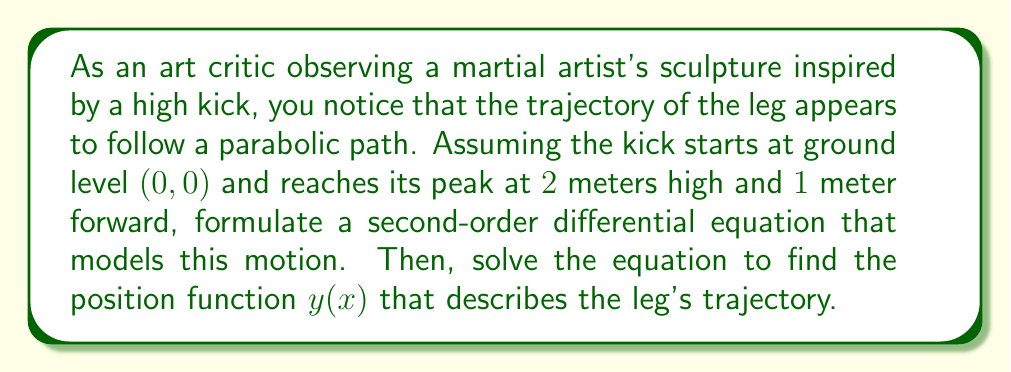Show me your answer to this math problem. Let's approach this step-by-step:

1) The parabolic trajectory suggests that the acceleration is constant (like gravity). We can model this with a second-order differential equation:

   $$\frac{d^2y}{dx^2} = k$$

   where $k$ is a constant.

2) We know three points on the trajectory:
   - Start: (0,0)
   - Peak: (1,2)
   - End: (2,0) (assuming symmetry)

3) The general solution to this differential equation is:

   $$y(x) = \frac{1}{2}kx^2 + ax + b$$

   where $a$ and $b$ are constants we need to determine.

4) Using the three known points:
   - (0,0): $b = 0$
   - (1,2): $2 = \frac{1}{2}k + a$
   - (2,0): $0 = 2k + 2a$

5) From the last equation: $a = -k$

6) Substituting into the second equation:
   $2 = \frac{1}{2}k - k$
   $2 = -\frac{1}{2}k$
   $k = -4$

7) Therefore, the position function is:

   $$y(x) = -2x^2 + 4x$$

8) To verify, we can check:
   - $y(0) = 0$
   - $y(1) = -2 + 4 = 2$
   - $y(2) = -8 + 8 = 0$

9) The second-order differential equation is thus:

   $$\frac{d^2y}{dx^2} = -4$$
Answer: The second-order differential equation modeling the leg's trajectory is:

$$\frac{d^2y}{dx^2} = -4$$

The position function describing the leg's trajectory is:

$$y(x) = -2x^2 + 4x$$ 